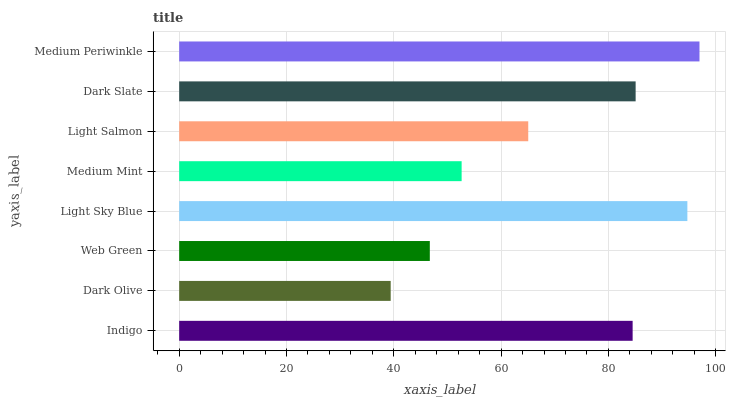Is Dark Olive the minimum?
Answer yes or no. Yes. Is Medium Periwinkle the maximum?
Answer yes or no. Yes. Is Web Green the minimum?
Answer yes or no. No. Is Web Green the maximum?
Answer yes or no. No. Is Web Green greater than Dark Olive?
Answer yes or no. Yes. Is Dark Olive less than Web Green?
Answer yes or no. Yes. Is Dark Olive greater than Web Green?
Answer yes or no. No. Is Web Green less than Dark Olive?
Answer yes or no. No. Is Indigo the high median?
Answer yes or no. Yes. Is Light Salmon the low median?
Answer yes or no. Yes. Is Light Sky Blue the high median?
Answer yes or no. No. Is Web Green the low median?
Answer yes or no. No. 